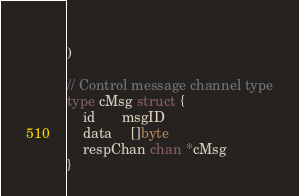<code> <loc_0><loc_0><loc_500><loc_500><_Go_>	
)

// Control message channel type
type cMsg struct {
	id       msgID
	data     []byte
	respChan chan *cMsg
}</code> 